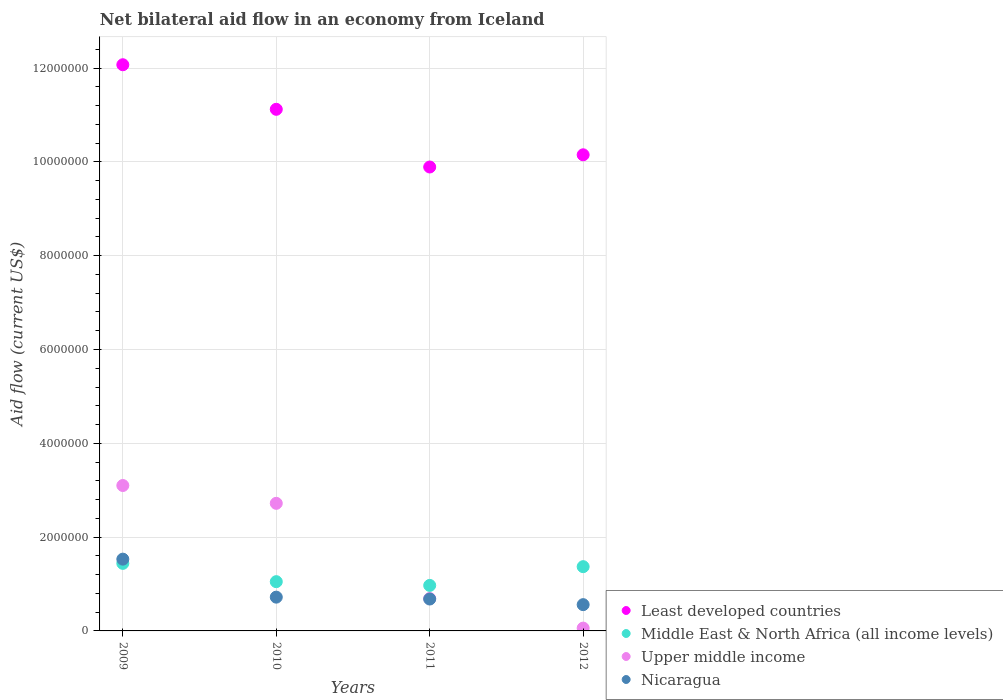Is the number of dotlines equal to the number of legend labels?
Offer a terse response. Yes. What is the net bilateral aid flow in Least developed countries in 2012?
Offer a terse response. 1.02e+07. Across all years, what is the maximum net bilateral aid flow in Middle East & North Africa (all income levels)?
Your response must be concise. 1.44e+06. Across all years, what is the minimum net bilateral aid flow in Upper middle income?
Ensure brevity in your answer.  6.00e+04. In which year was the net bilateral aid flow in Upper middle income maximum?
Make the answer very short. 2009. What is the total net bilateral aid flow in Upper middle income in the graph?
Make the answer very short. 6.57e+06. What is the difference between the net bilateral aid flow in Least developed countries in 2012 and the net bilateral aid flow in Middle East & North Africa (all income levels) in 2010?
Offer a very short reply. 9.10e+06. What is the average net bilateral aid flow in Middle East & North Africa (all income levels) per year?
Provide a succinct answer. 1.21e+06. In the year 2012, what is the difference between the net bilateral aid flow in Middle East & North Africa (all income levels) and net bilateral aid flow in Nicaragua?
Offer a very short reply. 8.10e+05. In how many years, is the net bilateral aid flow in Least developed countries greater than 5200000 US$?
Keep it short and to the point. 4. What is the ratio of the net bilateral aid flow in Nicaragua in 2009 to that in 2010?
Provide a short and direct response. 2.12. Is the net bilateral aid flow in Upper middle income in 2010 less than that in 2012?
Keep it short and to the point. No. Is the difference between the net bilateral aid flow in Middle East & North Africa (all income levels) in 2009 and 2011 greater than the difference between the net bilateral aid flow in Nicaragua in 2009 and 2011?
Give a very brief answer. No. What is the difference between the highest and the second highest net bilateral aid flow in Upper middle income?
Ensure brevity in your answer.  3.80e+05. What is the difference between the highest and the lowest net bilateral aid flow in Least developed countries?
Provide a short and direct response. 2.18e+06. In how many years, is the net bilateral aid flow in Middle East & North Africa (all income levels) greater than the average net bilateral aid flow in Middle East & North Africa (all income levels) taken over all years?
Give a very brief answer. 2. Is it the case that in every year, the sum of the net bilateral aid flow in Upper middle income and net bilateral aid flow in Least developed countries  is greater than the sum of net bilateral aid flow in Middle East & North Africa (all income levels) and net bilateral aid flow in Nicaragua?
Provide a short and direct response. Yes. Does the net bilateral aid flow in Middle East & North Africa (all income levels) monotonically increase over the years?
Provide a succinct answer. No. Is the net bilateral aid flow in Middle East & North Africa (all income levels) strictly less than the net bilateral aid flow in Nicaragua over the years?
Ensure brevity in your answer.  No. How many dotlines are there?
Offer a very short reply. 4. What is the difference between two consecutive major ticks on the Y-axis?
Make the answer very short. 2.00e+06. Are the values on the major ticks of Y-axis written in scientific E-notation?
Your answer should be very brief. No. Does the graph contain grids?
Your response must be concise. Yes. Where does the legend appear in the graph?
Provide a short and direct response. Bottom right. What is the title of the graph?
Keep it short and to the point. Net bilateral aid flow in an economy from Iceland. What is the label or title of the X-axis?
Your response must be concise. Years. What is the label or title of the Y-axis?
Provide a succinct answer. Aid flow (current US$). What is the Aid flow (current US$) of Least developed countries in 2009?
Keep it short and to the point. 1.21e+07. What is the Aid flow (current US$) of Middle East & North Africa (all income levels) in 2009?
Offer a terse response. 1.44e+06. What is the Aid flow (current US$) in Upper middle income in 2009?
Provide a succinct answer. 3.10e+06. What is the Aid flow (current US$) in Nicaragua in 2009?
Your response must be concise. 1.53e+06. What is the Aid flow (current US$) of Least developed countries in 2010?
Ensure brevity in your answer.  1.11e+07. What is the Aid flow (current US$) in Middle East & North Africa (all income levels) in 2010?
Provide a short and direct response. 1.05e+06. What is the Aid flow (current US$) in Upper middle income in 2010?
Offer a terse response. 2.72e+06. What is the Aid flow (current US$) of Nicaragua in 2010?
Give a very brief answer. 7.20e+05. What is the Aid flow (current US$) of Least developed countries in 2011?
Your answer should be very brief. 9.89e+06. What is the Aid flow (current US$) in Middle East & North Africa (all income levels) in 2011?
Provide a succinct answer. 9.70e+05. What is the Aid flow (current US$) of Upper middle income in 2011?
Offer a terse response. 6.90e+05. What is the Aid flow (current US$) of Nicaragua in 2011?
Provide a succinct answer. 6.80e+05. What is the Aid flow (current US$) in Least developed countries in 2012?
Your response must be concise. 1.02e+07. What is the Aid flow (current US$) of Middle East & North Africa (all income levels) in 2012?
Make the answer very short. 1.37e+06. What is the Aid flow (current US$) in Nicaragua in 2012?
Keep it short and to the point. 5.60e+05. Across all years, what is the maximum Aid flow (current US$) of Least developed countries?
Your answer should be compact. 1.21e+07. Across all years, what is the maximum Aid flow (current US$) in Middle East & North Africa (all income levels)?
Make the answer very short. 1.44e+06. Across all years, what is the maximum Aid flow (current US$) of Upper middle income?
Offer a terse response. 3.10e+06. Across all years, what is the maximum Aid flow (current US$) of Nicaragua?
Your answer should be compact. 1.53e+06. Across all years, what is the minimum Aid flow (current US$) of Least developed countries?
Provide a short and direct response. 9.89e+06. Across all years, what is the minimum Aid flow (current US$) of Middle East & North Africa (all income levels)?
Ensure brevity in your answer.  9.70e+05. Across all years, what is the minimum Aid flow (current US$) in Upper middle income?
Your answer should be very brief. 6.00e+04. Across all years, what is the minimum Aid flow (current US$) in Nicaragua?
Ensure brevity in your answer.  5.60e+05. What is the total Aid flow (current US$) of Least developed countries in the graph?
Keep it short and to the point. 4.32e+07. What is the total Aid flow (current US$) of Middle East & North Africa (all income levels) in the graph?
Offer a terse response. 4.83e+06. What is the total Aid flow (current US$) of Upper middle income in the graph?
Your response must be concise. 6.57e+06. What is the total Aid flow (current US$) of Nicaragua in the graph?
Provide a short and direct response. 3.49e+06. What is the difference between the Aid flow (current US$) of Least developed countries in 2009 and that in 2010?
Keep it short and to the point. 9.50e+05. What is the difference between the Aid flow (current US$) of Upper middle income in 2009 and that in 2010?
Provide a short and direct response. 3.80e+05. What is the difference between the Aid flow (current US$) of Nicaragua in 2009 and that in 2010?
Offer a terse response. 8.10e+05. What is the difference between the Aid flow (current US$) of Least developed countries in 2009 and that in 2011?
Your response must be concise. 2.18e+06. What is the difference between the Aid flow (current US$) of Upper middle income in 2009 and that in 2011?
Your answer should be very brief. 2.41e+06. What is the difference between the Aid flow (current US$) in Nicaragua in 2009 and that in 2011?
Offer a terse response. 8.50e+05. What is the difference between the Aid flow (current US$) of Least developed countries in 2009 and that in 2012?
Your answer should be very brief. 1.92e+06. What is the difference between the Aid flow (current US$) in Middle East & North Africa (all income levels) in 2009 and that in 2012?
Make the answer very short. 7.00e+04. What is the difference between the Aid flow (current US$) in Upper middle income in 2009 and that in 2012?
Give a very brief answer. 3.04e+06. What is the difference between the Aid flow (current US$) in Nicaragua in 2009 and that in 2012?
Provide a short and direct response. 9.70e+05. What is the difference between the Aid flow (current US$) in Least developed countries in 2010 and that in 2011?
Provide a succinct answer. 1.23e+06. What is the difference between the Aid flow (current US$) of Upper middle income in 2010 and that in 2011?
Your answer should be compact. 2.03e+06. What is the difference between the Aid flow (current US$) of Nicaragua in 2010 and that in 2011?
Give a very brief answer. 4.00e+04. What is the difference between the Aid flow (current US$) in Least developed countries in 2010 and that in 2012?
Your response must be concise. 9.70e+05. What is the difference between the Aid flow (current US$) of Middle East & North Africa (all income levels) in 2010 and that in 2012?
Your answer should be very brief. -3.20e+05. What is the difference between the Aid flow (current US$) in Upper middle income in 2010 and that in 2012?
Keep it short and to the point. 2.66e+06. What is the difference between the Aid flow (current US$) in Least developed countries in 2011 and that in 2012?
Ensure brevity in your answer.  -2.60e+05. What is the difference between the Aid flow (current US$) in Middle East & North Africa (all income levels) in 2011 and that in 2012?
Keep it short and to the point. -4.00e+05. What is the difference between the Aid flow (current US$) in Upper middle income in 2011 and that in 2012?
Make the answer very short. 6.30e+05. What is the difference between the Aid flow (current US$) in Nicaragua in 2011 and that in 2012?
Make the answer very short. 1.20e+05. What is the difference between the Aid flow (current US$) in Least developed countries in 2009 and the Aid flow (current US$) in Middle East & North Africa (all income levels) in 2010?
Keep it short and to the point. 1.10e+07. What is the difference between the Aid flow (current US$) in Least developed countries in 2009 and the Aid flow (current US$) in Upper middle income in 2010?
Your answer should be very brief. 9.35e+06. What is the difference between the Aid flow (current US$) of Least developed countries in 2009 and the Aid flow (current US$) of Nicaragua in 2010?
Give a very brief answer. 1.14e+07. What is the difference between the Aid flow (current US$) of Middle East & North Africa (all income levels) in 2009 and the Aid flow (current US$) of Upper middle income in 2010?
Ensure brevity in your answer.  -1.28e+06. What is the difference between the Aid flow (current US$) of Middle East & North Africa (all income levels) in 2009 and the Aid flow (current US$) of Nicaragua in 2010?
Ensure brevity in your answer.  7.20e+05. What is the difference between the Aid flow (current US$) in Upper middle income in 2009 and the Aid flow (current US$) in Nicaragua in 2010?
Your answer should be very brief. 2.38e+06. What is the difference between the Aid flow (current US$) in Least developed countries in 2009 and the Aid flow (current US$) in Middle East & North Africa (all income levels) in 2011?
Your response must be concise. 1.11e+07. What is the difference between the Aid flow (current US$) of Least developed countries in 2009 and the Aid flow (current US$) of Upper middle income in 2011?
Your answer should be very brief. 1.14e+07. What is the difference between the Aid flow (current US$) in Least developed countries in 2009 and the Aid flow (current US$) in Nicaragua in 2011?
Your answer should be very brief. 1.14e+07. What is the difference between the Aid flow (current US$) of Middle East & North Africa (all income levels) in 2009 and the Aid flow (current US$) of Upper middle income in 2011?
Give a very brief answer. 7.50e+05. What is the difference between the Aid flow (current US$) of Middle East & North Africa (all income levels) in 2009 and the Aid flow (current US$) of Nicaragua in 2011?
Offer a terse response. 7.60e+05. What is the difference between the Aid flow (current US$) of Upper middle income in 2009 and the Aid flow (current US$) of Nicaragua in 2011?
Ensure brevity in your answer.  2.42e+06. What is the difference between the Aid flow (current US$) of Least developed countries in 2009 and the Aid flow (current US$) of Middle East & North Africa (all income levels) in 2012?
Your response must be concise. 1.07e+07. What is the difference between the Aid flow (current US$) in Least developed countries in 2009 and the Aid flow (current US$) in Upper middle income in 2012?
Keep it short and to the point. 1.20e+07. What is the difference between the Aid flow (current US$) of Least developed countries in 2009 and the Aid flow (current US$) of Nicaragua in 2012?
Your answer should be very brief. 1.15e+07. What is the difference between the Aid flow (current US$) in Middle East & North Africa (all income levels) in 2009 and the Aid flow (current US$) in Upper middle income in 2012?
Ensure brevity in your answer.  1.38e+06. What is the difference between the Aid flow (current US$) in Middle East & North Africa (all income levels) in 2009 and the Aid flow (current US$) in Nicaragua in 2012?
Ensure brevity in your answer.  8.80e+05. What is the difference between the Aid flow (current US$) in Upper middle income in 2009 and the Aid flow (current US$) in Nicaragua in 2012?
Keep it short and to the point. 2.54e+06. What is the difference between the Aid flow (current US$) of Least developed countries in 2010 and the Aid flow (current US$) of Middle East & North Africa (all income levels) in 2011?
Offer a terse response. 1.02e+07. What is the difference between the Aid flow (current US$) of Least developed countries in 2010 and the Aid flow (current US$) of Upper middle income in 2011?
Offer a very short reply. 1.04e+07. What is the difference between the Aid flow (current US$) of Least developed countries in 2010 and the Aid flow (current US$) of Nicaragua in 2011?
Provide a succinct answer. 1.04e+07. What is the difference between the Aid flow (current US$) in Middle East & North Africa (all income levels) in 2010 and the Aid flow (current US$) in Upper middle income in 2011?
Make the answer very short. 3.60e+05. What is the difference between the Aid flow (current US$) in Middle East & North Africa (all income levels) in 2010 and the Aid flow (current US$) in Nicaragua in 2011?
Provide a succinct answer. 3.70e+05. What is the difference between the Aid flow (current US$) in Upper middle income in 2010 and the Aid flow (current US$) in Nicaragua in 2011?
Provide a short and direct response. 2.04e+06. What is the difference between the Aid flow (current US$) in Least developed countries in 2010 and the Aid flow (current US$) in Middle East & North Africa (all income levels) in 2012?
Your answer should be compact. 9.75e+06. What is the difference between the Aid flow (current US$) in Least developed countries in 2010 and the Aid flow (current US$) in Upper middle income in 2012?
Your answer should be compact. 1.11e+07. What is the difference between the Aid flow (current US$) of Least developed countries in 2010 and the Aid flow (current US$) of Nicaragua in 2012?
Provide a succinct answer. 1.06e+07. What is the difference between the Aid flow (current US$) of Middle East & North Africa (all income levels) in 2010 and the Aid flow (current US$) of Upper middle income in 2012?
Keep it short and to the point. 9.90e+05. What is the difference between the Aid flow (current US$) of Middle East & North Africa (all income levels) in 2010 and the Aid flow (current US$) of Nicaragua in 2012?
Offer a very short reply. 4.90e+05. What is the difference between the Aid flow (current US$) of Upper middle income in 2010 and the Aid flow (current US$) of Nicaragua in 2012?
Ensure brevity in your answer.  2.16e+06. What is the difference between the Aid flow (current US$) in Least developed countries in 2011 and the Aid flow (current US$) in Middle East & North Africa (all income levels) in 2012?
Your answer should be compact. 8.52e+06. What is the difference between the Aid flow (current US$) of Least developed countries in 2011 and the Aid flow (current US$) of Upper middle income in 2012?
Offer a terse response. 9.83e+06. What is the difference between the Aid flow (current US$) in Least developed countries in 2011 and the Aid flow (current US$) in Nicaragua in 2012?
Provide a short and direct response. 9.33e+06. What is the difference between the Aid flow (current US$) in Middle East & North Africa (all income levels) in 2011 and the Aid flow (current US$) in Upper middle income in 2012?
Provide a short and direct response. 9.10e+05. What is the difference between the Aid flow (current US$) of Middle East & North Africa (all income levels) in 2011 and the Aid flow (current US$) of Nicaragua in 2012?
Your response must be concise. 4.10e+05. What is the difference between the Aid flow (current US$) of Upper middle income in 2011 and the Aid flow (current US$) of Nicaragua in 2012?
Your answer should be compact. 1.30e+05. What is the average Aid flow (current US$) of Least developed countries per year?
Provide a short and direct response. 1.08e+07. What is the average Aid flow (current US$) in Middle East & North Africa (all income levels) per year?
Keep it short and to the point. 1.21e+06. What is the average Aid flow (current US$) in Upper middle income per year?
Your answer should be compact. 1.64e+06. What is the average Aid flow (current US$) of Nicaragua per year?
Your response must be concise. 8.72e+05. In the year 2009, what is the difference between the Aid flow (current US$) in Least developed countries and Aid flow (current US$) in Middle East & North Africa (all income levels)?
Offer a terse response. 1.06e+07. In the year 2009, what is the difference between the Aid flow (current US$) of Least developed countries and Aid flow (current US$) of Upper middle income?
Your answer should be compact. 8.97e+06. In the year 2009, what is the difference between the Aid flow (current US$) in Least developed countries and Aid flow (current US$) in Nicaragua?
Give a very brief answer. 1.05e+07. In the year 2009, what is the difference between the Aid flow (current US$) in Middle East & North Africa (all income levels) and Aid flow (current US$) in Upper middle income?
Ensure brevity in your answer.  -1.66e+06. In the year 2009, what is the difference between the Aid flow (current US$) of Middle East & North Africa (all income levels) and Aid flow (current US$) of Nicaragua?
Give a very brief answer. -9.00e+04. In the year 2009, what is the difference between the Aid flow (current US$) in Upper middle income and Aid flow (current US$) in Nicaragua?
Give a very brief answer. 1.57e+06. In the year 2010, what is the difference between the Aid flow (current US$) in Least developed countries and Aid flow (current US$) in Middle East & North Africa (all income levels)?
Keep it short and to the point. 1.01e+07. In the year 2010, what is the difference between the Aid flow (current US$) of Least developed countries and Aid flow (current US$) of Upper middle income?
Your response must be concise. 8.40e+06. In the year 2010, what is the difference between the Aid flow (current US$) in Least developed countries and Aid flow (current US$) in Nicaragua?
Your answer should be very brief. 1.04e+07. In the year 2010, what is the difference between the Aid flow (current US$) in Middle East & North Africa (all income levels) and Aid flow (current US$) in Upper middle income?
Offer a very short reply. -1.67e+06. In the year 2011, what is the difference between the Aid flow (current US$) in Least developed countries and Aid flow (current US$) in Middle East & North Africa (all income levels)?
Offer a terse response. 8.92e+06. In the year 2011, what is the difference between the Aid flow (current US$) in Least developed countries and Aid flow (current US$) in Upper middle income?
Ensure brevity in your answer.  9.20e+06. In the year 2011, what is the difference between the Aid flow (current US$) in Least developed countries and Aid flow (current US$) in Nicaragua?
Ensure brevity in your answer.  9.21e+06. In the year 2011, what is the difference between the Aid flow (current US$) of Upper middle income and Aid flow (current US$) of Nicaragua?
Your answer should be compact. 10000. In the year 2012, what is the difference between the Aid flow (current US$) of Least developed countries and Aid flow (current US$) of Middle East & North Africa (all income levels)?
Keep it short and to the point. 8.78e+06. In the year 2012, what is the difference between the Aid flow (current US$) of Least developed countries and Aid flow (current US$) of Upper middle income?
Ensure brevity in your answer.  1.01e+07. In the year 2012, what is the difference between the Aid flow (current US$) of Least developed countries and Aid flow (current US$) of Nicaragua?
Your answer should be compact. 9.59e+06. In the year 2012, what is the difference between the Aid flow (current US$) of Middle East & North Africa (all income levels) and Aid flow (current US$) of Upper middle income?
Your response must be concise. 1.31e+06. In the year 2012, what is the difference between the Aid flow (current US$) of Middle East & North Africa (all income levels) and Aid flow (current US$) of Nicaragua?
Make the answer very short. 8.10e+05. In the year 2012, what is the difference between the Aid flow (current US$) in Upper middle income and Aid flow (current US$) in Nicaragua?
Keep it short and to the point. -5.00e+05. What is the ratio of the Aid flow (current US$) of Least developed countries in 2009 to that in 2010?
Your answer should be very brief. 1.09. What is the ratio of the Aid flow (current US$) of Middle East & North Africa (all income levels) in 2009 to that in 2010?
Give a very brief answer. 1.37. What is the ratio of the Aid flow (current US$) in Upper middle income in 2009 to that in 2010?
Give a very brief answer. 1.14. What is the ratio of the Aid flow (current US$) in Nicaragua in 2009 to that in 2010?
Provide a succinct answer. 2.12. What is the ratio of the Aid flow (current US$) in Least developed countries in 2009 to that in 2011?
Provide a short and direct response. 1.22. What is the ratio of the Aid flow (current US$) in Middle East & North Africa (all income levels) in 2009 to that in 2011?
Keep it short and to the point. 1.48. What is the ratio of the Aid flow (current US$) in Upper middle income in 2009 to that in 2011?
Your answer should be compact. 4.49. What is the ratio of the Aid flow (current US$) in Nicaragua in 2009 to that in 2011?
Make the answer very short. 2.25. What is the ratio of the Aid flow (current US$) of Least developed countries in 2009 to that in 2012?
Your answer should be very brief. 1.19. What is the ratio of the Aid flow (current US$) in Middle East & North Africa (all income levels) in 2009 to that in 2012?
Provide a short and direct response. 1.05. What is the ratio of the Aid flow (current US$) in Upper middle income in 2009 to that in 2012?
Give a very brief answer. 51.67. What is the ratio of the Aid flow (current US$) in Nicaragua in 2009 to that in 2012?
Offer a terse response. 2.73. What is the ratio of the Aid flow (current US$) of Least developed countries in 2010 to that in 2011?
Your answer should be compact. 1.12. What is the ratio of the Aid flow (current US$) in Middle East & North Africa (all income levels) in 2010 to that in 2011?
Provide a short and direct response. 1.08. What is the ratio of the Aid flow (current US$) of Upper middle income in 2010 to that in 2011?
Offer a terse response. 3.94. What is the ratio of the Aid flow (current US$) of Nicaragua in 2010 to that in 2011?
Ensure brevity in your answer.  1.06. What is the ratio of the Aid flow (current US$) in Least developed countries in 2010 to that in 2012?
Provide a short and direct response. 1.1. What is the ratio of the Aid flow (current US$) of Middle East & North Africa (all income levels) in 2010 to that in 2012?
Make the answer very short. 0.77. What is the ratio of the Aid flow (current US$) of Upper middle income in 2010 to that in 2012?
Offer a very short reply. 45.33. What is the ratio of the Aid flow (current US$) in Nicaragua in 2010 to that in 2012?
Make the answer very short. 1.29. What is the ratio of the Aid flow (current US$) in Least developed countries in 2011 to that in 2012?
Your answer should be very brief. 0.97. What is the ratio of the Aid flow (current US$) in Middle East & North Africa (all income levels) in 2011 to that in 2012?
Ensure brevity in your answer.  0.71. What is the ratio of the Aid flow (current US$) of Nicaragua in 2011 to that in 2012?
Offer a terse response. 1.21. What is the difference between the highest and the second highest Aid flow (current US$) of Least developed countries?
Offer a terse response. 9.50e+05. What is the difference between the highest and the second highest Aid flow (current US$) in Middle East & North Africa (all income levels)?
Your response must be concise. 7.00e+04. What is the difference between the highest and the second highest Aid flow (current US$) of Upper middle income?
Make the answer very short. 3.80e+05. What is the difference between the highest and the second highest Aid flow (current US$) in Nicaragua?
Keep it short and to the point. 8.10e+05. What is the difference between the highest and the lowest Aid flow (current US$) of Least developed countries?
Keep it short and to the point. 2.18e+06. What is the difference between the highest and the lowest Aid flow (current US$) in Middle East & North Africa (all income levels)?
Your answer should be very brief. 4.70e+05. What is the difference between the highest and the lowest Aid flow (current US$) of Upper middle income?
Your answer should be compact. 3.04e+06. What is the difference between the highest and the lowest Aid flow (current US$) in Nicaragua?
Provide a succinct answer. 9.70e+05. 